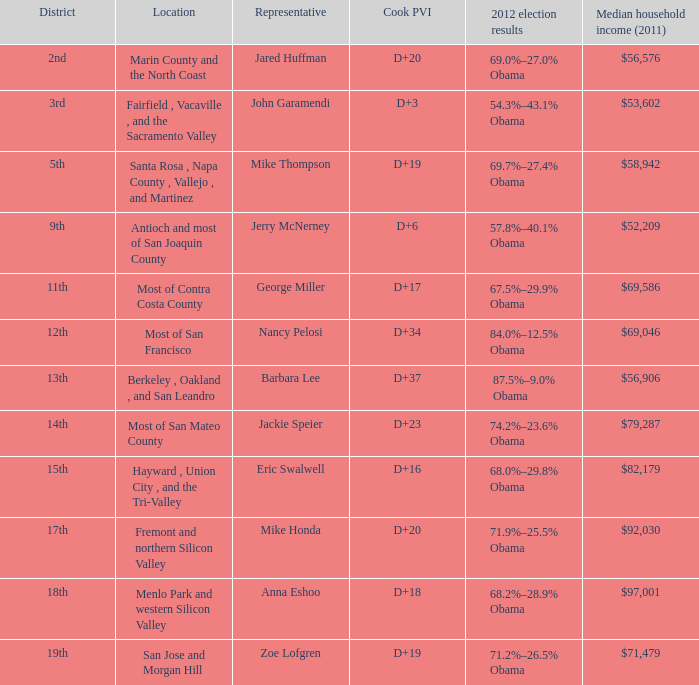What is the cook pvi for the place with a representative of mike thompson? D+19. 